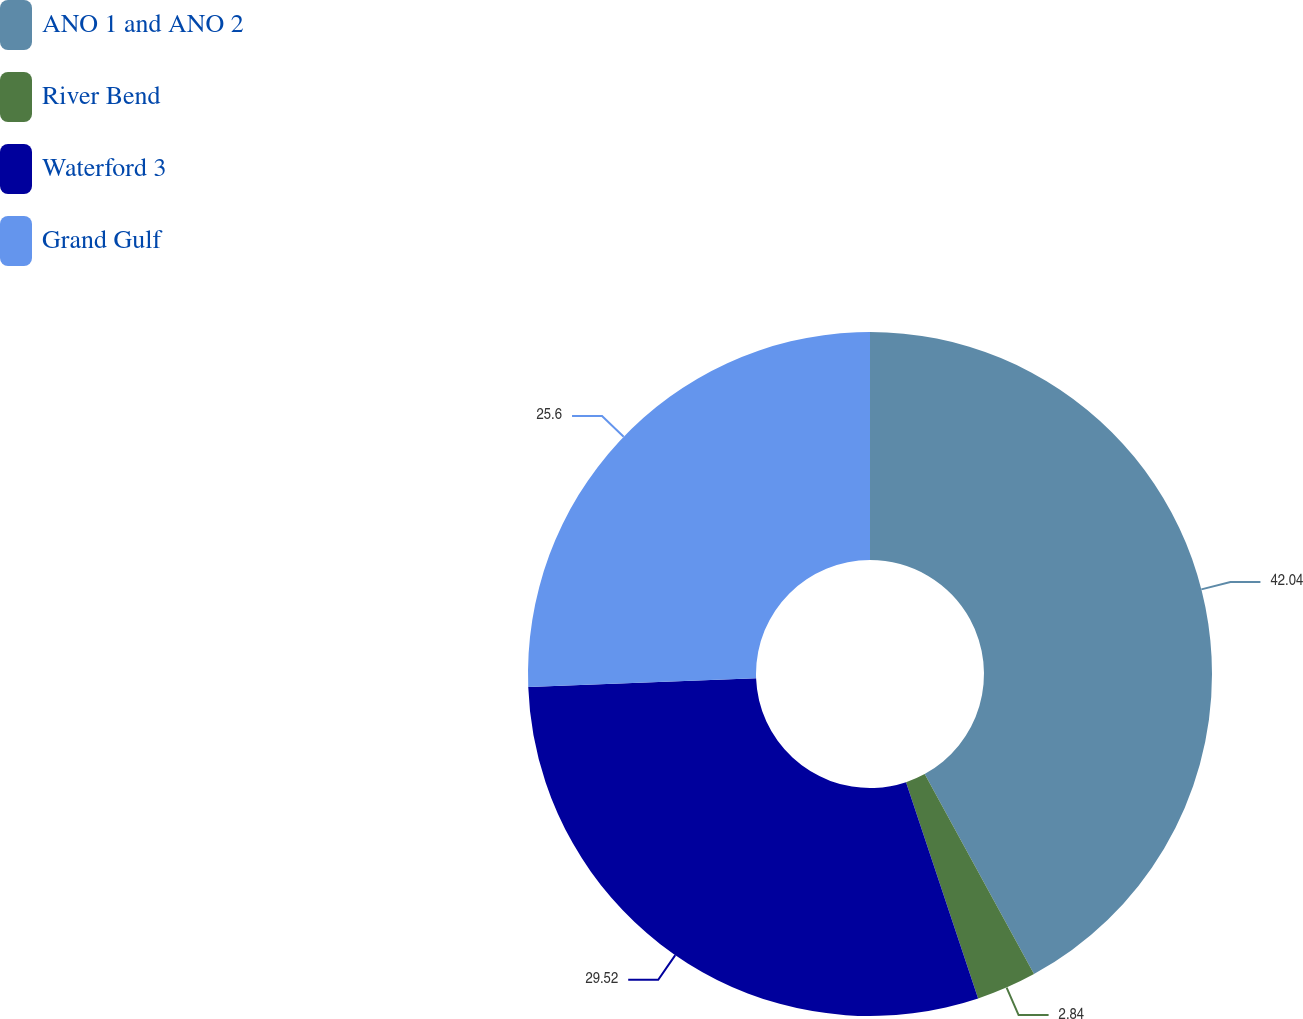Convert chart. <chart><loc_0><loc_0><loc_500><loc_500><pie_chart><fcel>ANO 1 and ANO 2<fcel>River Bend<fcel>Waterford 3<fcel>Grand Gulf<nl><fcel>42.04%<fcel>2.84%<fcel>29.52%<fcel>25.6%<nl></chart> 